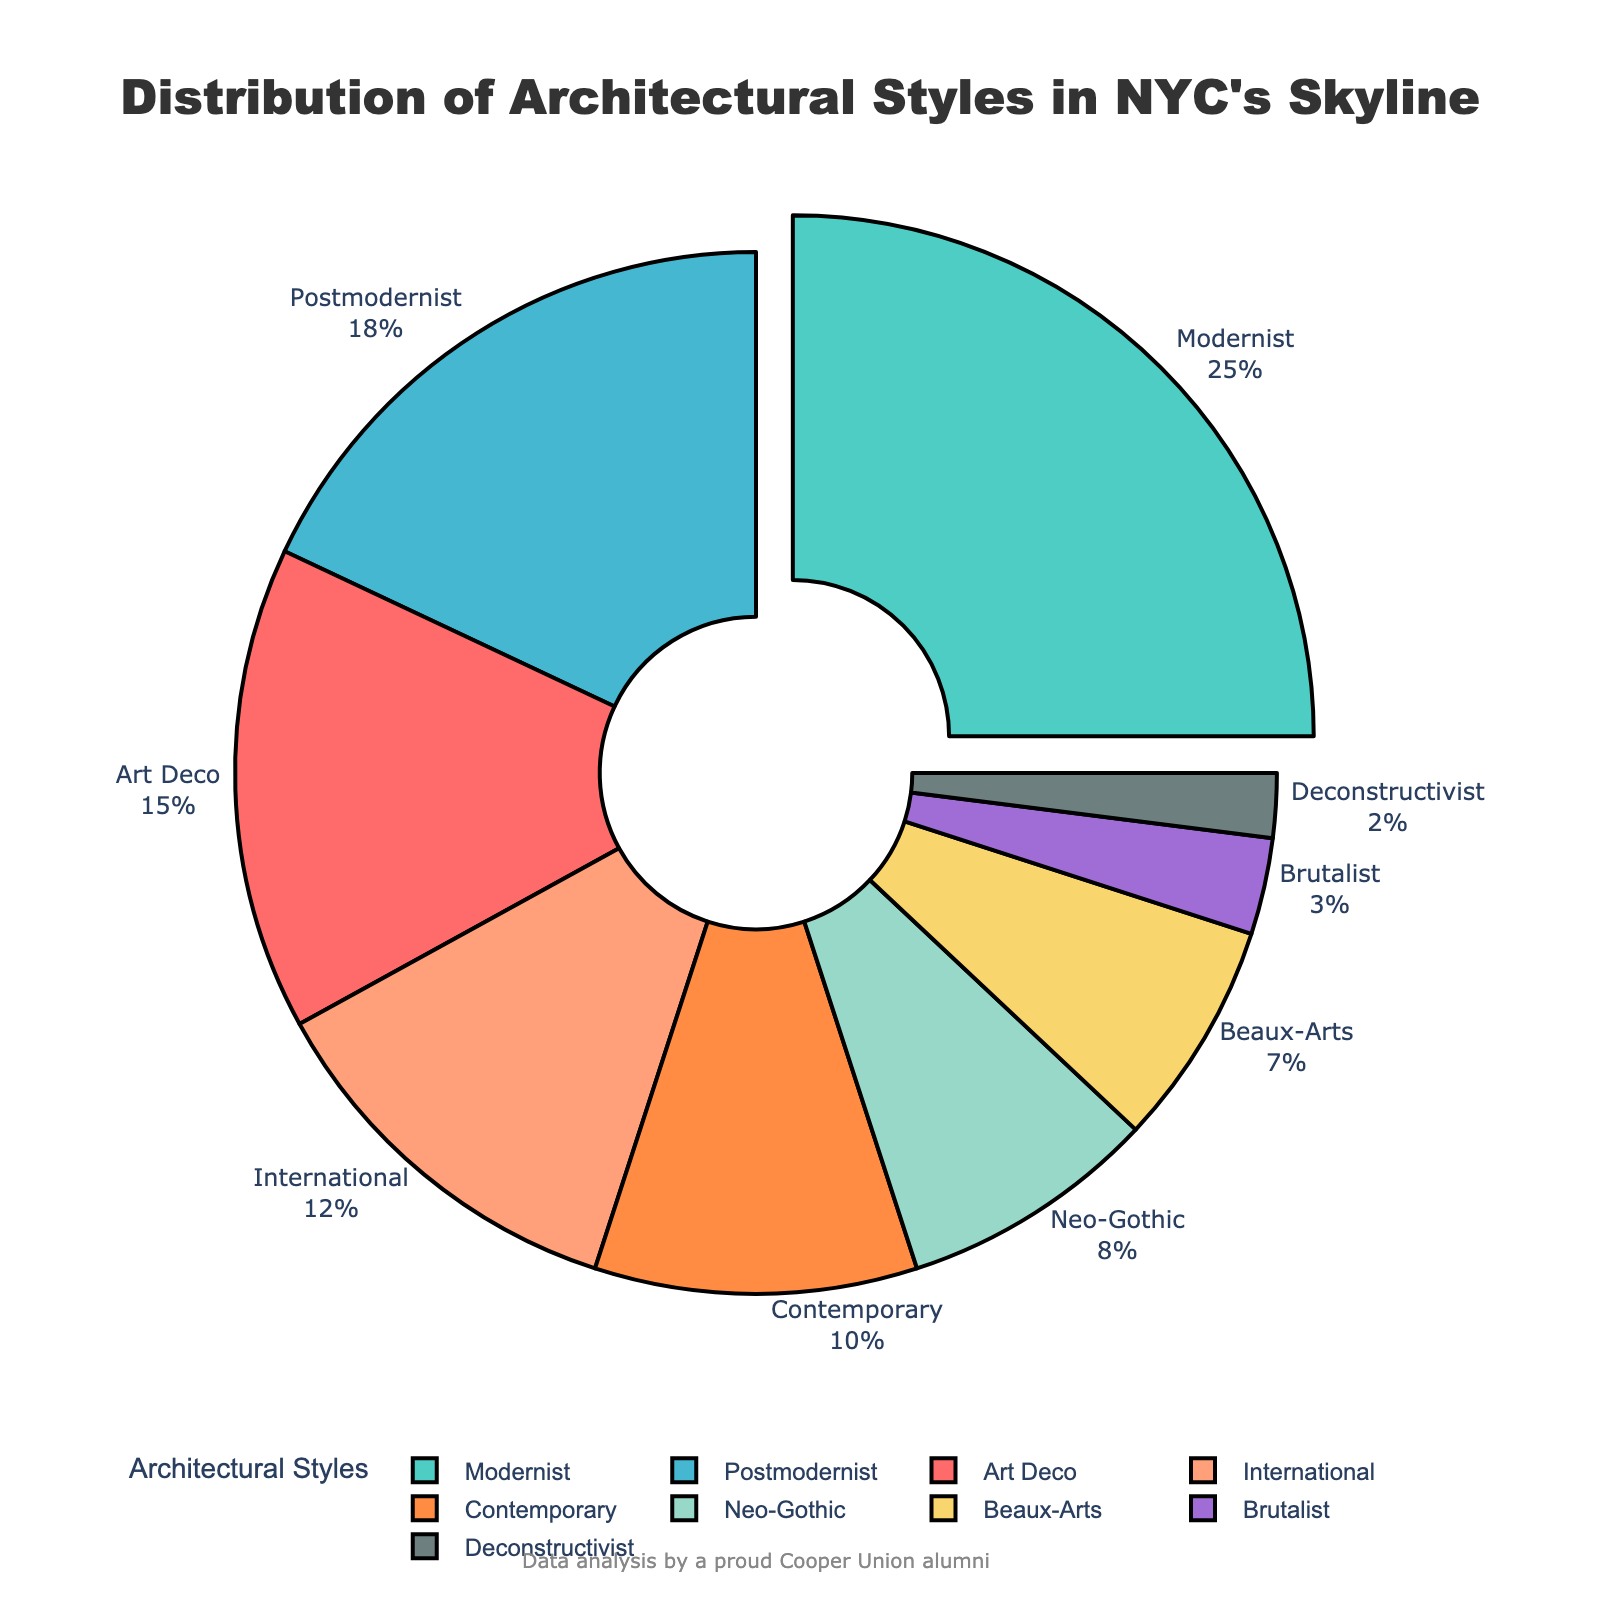What percentage of New York City's skyline is made up of Modernist and Postmodernist styles combined? First locate the percentages for Modernist and Postmodernist styles, which are 25% and 18% respectively. Then, sum them up: 25 + 18 = 43. Therefore, the combined percentage is 43%.
Answer: 43% Which architectural style has the second-highest percentage in New York City's skyline? Identify the highest percentage first, which is Modernist at 25%. Then find the next highest, which is Postmodernist at 18%.
Answer: Postmodernist Which architectural styles have percentages less than 10%? List the styles with percentages below 10%: Neo-Gothic 8%, Beaux-Arts 7%, Brutalist 3%, and Deconstructivist 2%. So the styles are Neo-Gothic, Beaux-Arts, Brutalist, and Deconstructivist.
Answer: Neo-Gothic, Beaux-Arts, Brutalist, Deconstructivist Which style is represented by the green section in the plot? Identify the color green used in the chart and match it with the corresponding label. In this case, green corresponds to the Modernist style.
Answer: Modernist How much larger is the percentage share of Art Deco compared to Brutalist? Art Deco has 15% and Brutalist has 3%. Subtract Brutalist from Art Deco: 15 - 3 = 12%. Therefore, Art Deco is 12% larger.
Answer: 12% What color represents the Beaux-Arts architectural style in the plot? Look for the label Beaux-Arts and identify its corresponding color, which is a shade of yellow.
Answer: Yellow Which architectural style has the smallest percentage in NYC's skyline? Identify the style with the lowest percentage, which is Deconstructivist at 2%.
Answer: Deconstructivist What is the sum of the percentages of International, Neo-Gothic, and Beaux-Arts styles? Add the percentages of International (12%), Neo-Gothic (8%), and Beaux-Arts (7%): 12 + 8 + 7 = 27%.
Answer: 27% Which architectural style is highlighted by being pulled out from the pie chart? The style that is pulled out is the one with the highest percentage, which is Modernist at 25%.
Answer: Modernist What percentage of New York City's skyline is made up by styles with percentages above 15%? Identify the styles with percentages above 15%, which are Modernist (25%) and Postmodernist (18%). Sum these percentages: 25 + 18 = 43%.
Answer: 43% 